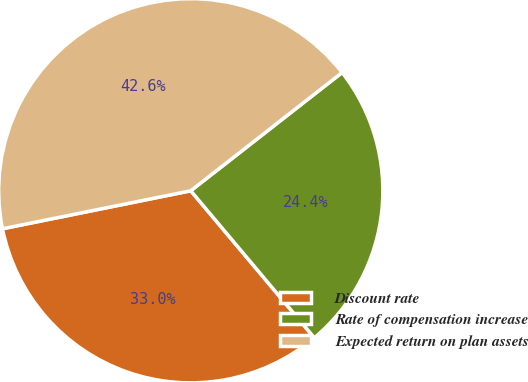<chart> <loc_0><loc_0><loc_500><loc_500><pie_chart><fcel>Discount rate<fcel>Rate of compensation increase<fcel>Expected return on plan assets<nl><fcel>32.95%<fcel>24.43%<fcel>42.61%<nl></chart> 